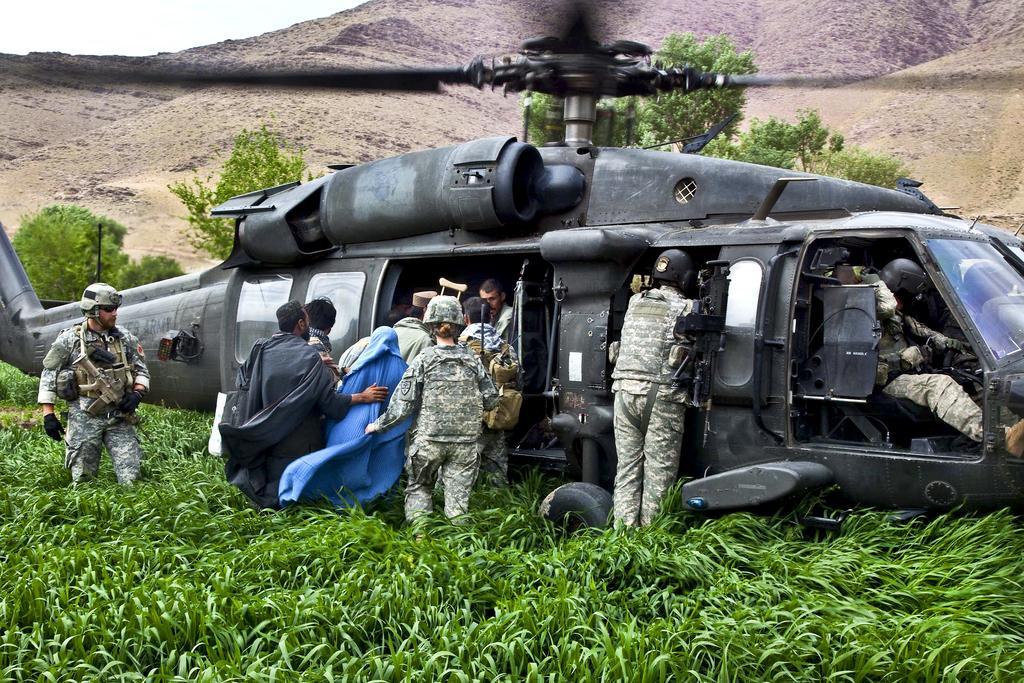Describe this image in one or two sentences. In the center of the image there is a chopper. There are people getting into chopper. In the bottom of there is grass. In the background of the image there are mountains. 